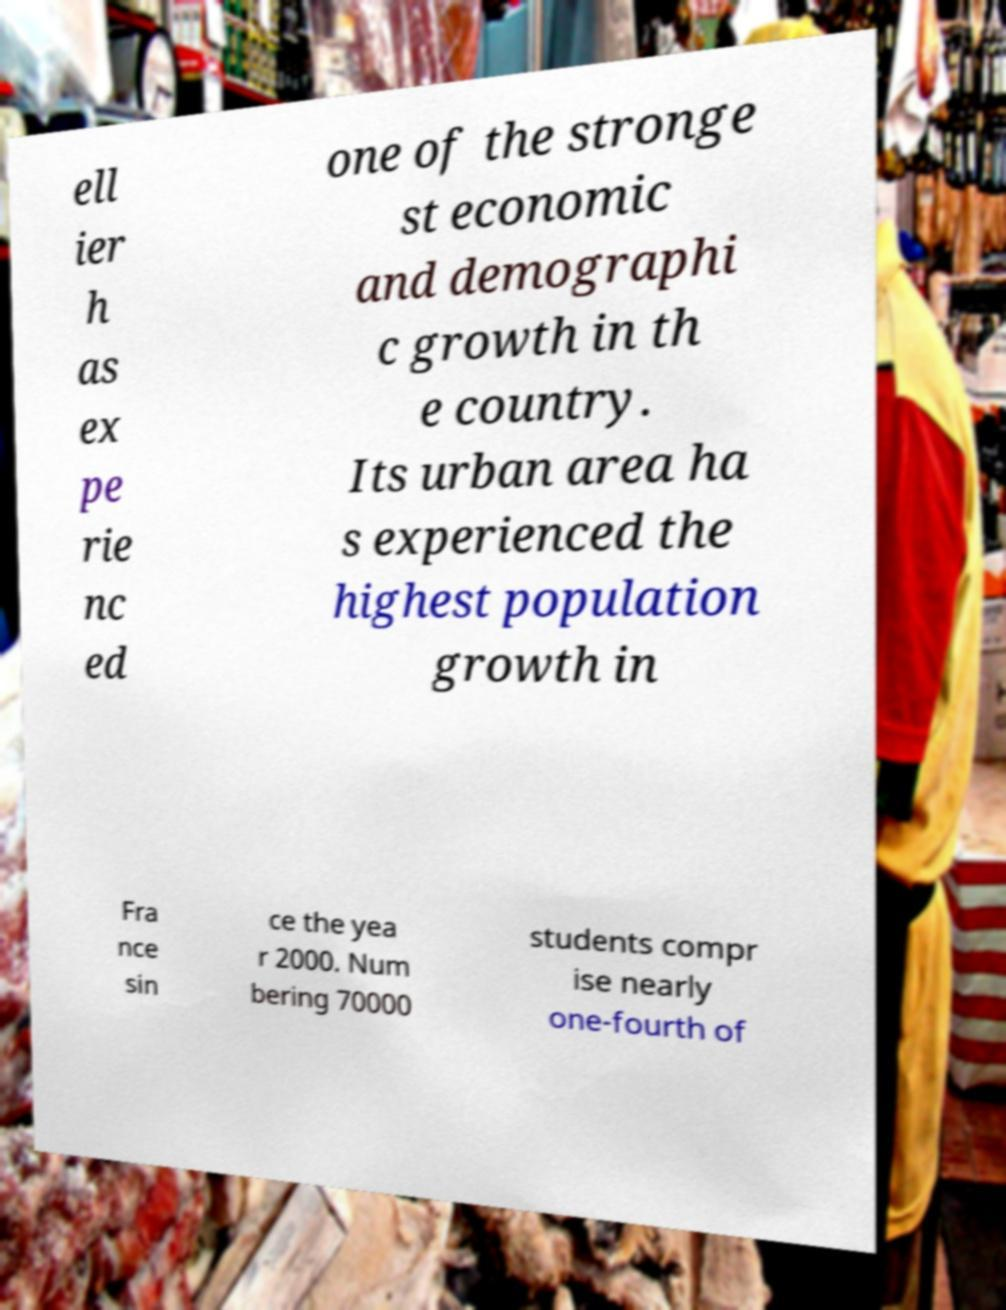Please read and relay the text visible in this image. What does it say? ell ier h as ex pe rie nc ed one of the stronge st economic and demographi c growth in th e country. Its urban area ha s experienced the highest population growth in Fra nce sin ce the yea r 2000. Num bering 70000 students compr ise nearly one-fourth of 